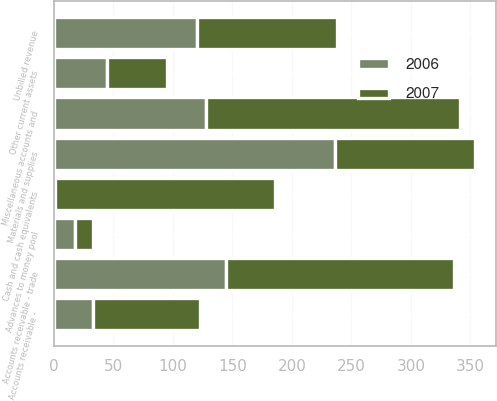Convert chart to OTSL. <chart><loc_0><loc_0><loc_500><loc_500><stacked_bar_chart><ecel><fcel>Cash and cash equivalents<fcel>Accounts receivable - trade<fcel>Unbilled revenue<fcel>Miscellaneous accounts and<fcel>Advances to money pool<fcel>Accounts receivable -<fcel>Materials and supplies<fcel>Other current assets<nl><fcel>2007<fcel>185<fcel>191<fcel>118<fcel>213<fcel>15<fcel>90<fcel>118<fcel>50<nl><fcel>2006<fcel>1<fcel>145<fcel>120<fcel>128<fcel>18<fcel>33<fcel>236<fcel>45<nl></chart> 